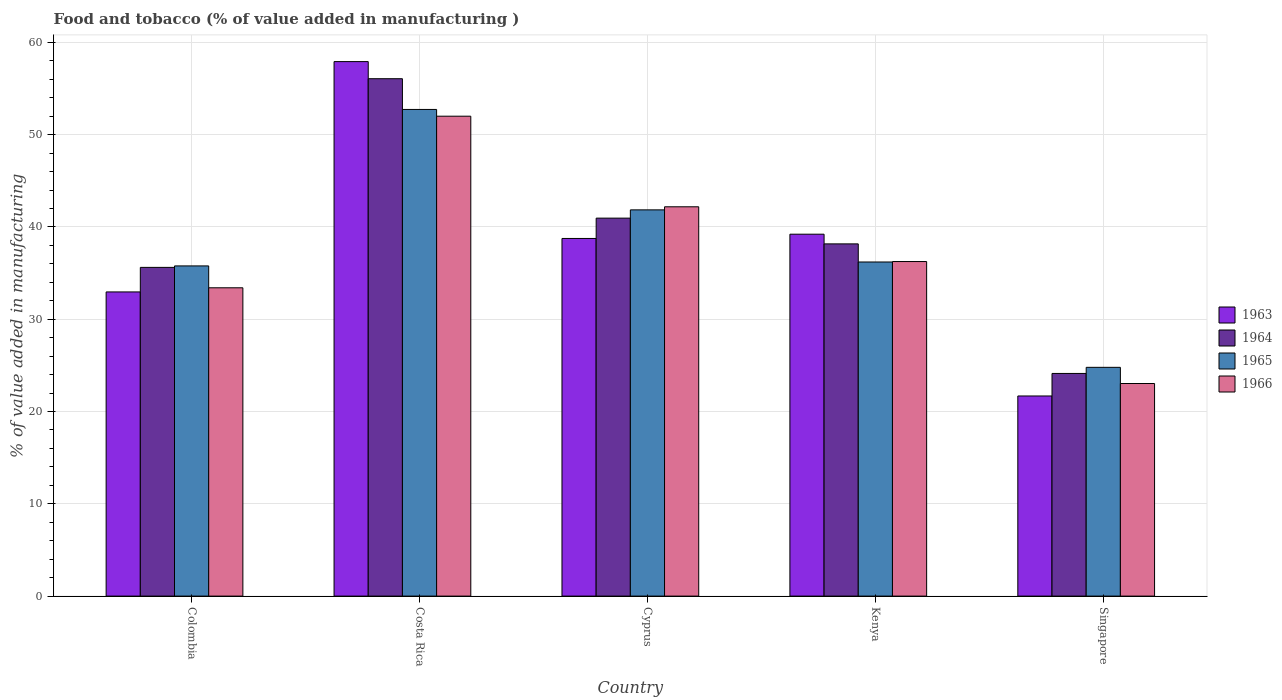How many groups of bars are there?
Your response must be concise. 5. Are the number of bars per tick equal to the number of legend labels?
Your response must be concise. Yes. Are the number of bars on each tick of the X-axis equal?
Offer a terse response. Yes. How many bars are there on the 2nd tick from the left?
Your answer should be compact. 4. What is the label of the 4th group of bars from the left?
Give a very brief answer. Kenya. What is the value added in manufacturing food and tobacco in 1964 in Colombia?
Keep it short and to the point. 35.62. Across all countries, what is the maximum value added in manufacturing food and tobacco in 1964?
Ensure brevity in your answer.  56.07. Across all countries, what is the minimum value added in manufacturing food and tobacco in 1965?
Keep it short and to the point. 24.79. In which country was the value added in manufacturing food and tobacco in 1964 maximum?
Your response must be concise. Costa Rica. In which country was the value added in manufacturing food and tobacco in 1966 minimum?
Provide a short and direct response. Singapore. What is the total value added in manufacturing food and tobacco in 1964 in the graph?
Provide a succinct answer. 194.94. What is the difference between the value added in manufacturing food and tobacco in 1964 in Costa Rica and that in Cyprus?
Offer a very short reply. 15.11. What is the difference between the value added in manufacturing food and tobacco in 1965 in Cyprus and the value added in manufacturing food and tobacco in 1964 in Kenya?
Provide a succinct answer. 3.69. What is the average value added in manufacturing food and tobacco in 1965 per country?
Provide a short and direct response. 38.27. What is the difference between the value added in manufacturing food and tobacco of/in 1963 and value added in manufacturing food and tobacco of/in 1966 in Singapore?
Make the answer very short. -1.35. What is the ratio of the value added in manufacturing food and tobacco in 1964 in Cyprus to that in Kenya?
Ensure brevity in your answer.  1.07. Is the difference between the value added in manufacturing food and tobacco in 1963 in Kenya and Singapore greater than the difference between the value added in manufacturing food and tobacco in 1966 in Kenya and Singapore?
Give a very brief answer. Yes. What is the difference between the highest and the second highest value added in manufacturing food and tobacco in 1964?
Offer a very short reply. 15.11. What is the difference between the highest and the lowest value added in manufacturing food and tobacco in 1965?
Make the answer very short. 27.94. In how many countries, is the value added in manufacturing food and tobacco in 1965 greater than the average value added in manufacturing food and tobacco in 1965 taken over all countries?
Provide a succinct answer. 2. Is the sum of the value added in manufacturing food and tobacco in 1965 in Costa Rica and Singapore greater than the maximum value added in manufacturing food and tobacco in 1966 across all countries?
Ensure brevity in your answer.  Yes. Is it the case that in every country, the sum of the value added in manufacturing food and tobacco in 1963 and value added in manufacturing food and tobacco in 1964 is greater than the sum of value added in manufacturing food and tobacco in 1965 and value added in manufacturing food and tobacco in 1966?
Your answer should be compact. No. What does the 1st bar from the right in Cyprus represents?
Offer a terse response. 1966. Is it the case that in every country, the sum of the value added in manufacturing food and tobacco in 1965 and value added in manufacturing food and tobacco in 1964 is greater than the value added in manufacturing food and tobacco in 1963?
Offer a terse response. Yes. How many bars are there?
Your answer should be compact. 20. Are all the bars in the graph horizontal?
Your answer should be very brief. No. How many countries are there in the graph?
Your response must be concise. 5. What is the difference between two consecutive major ticks on the Y-axis?
Provide a short and direct response. 10. Does the graph contain grids?
Provide a succinct answer. Yes. Where does the legend appear in the graph?
Keep it short and to the point. Center right. How many legend labels are there?
Give a very brief answer. 4. What is the title of the graph?
Offer a very short reply. Food and tobacco (% of value added in manufacturing ). Does "1961" appear as one of the legend labels in the graph?
Offer a terse response. No. What is the label or title of the X-axis?
Your answer should be very brief. Country. What is the label or title of the Y-axis?
Give a very brief answer. % of value added in manufacturing. What is the % of value added in manufacturing of 1963 in Colombia?
Make the answer very short. 32.96. What is the % of value added in manufacturing of 1964 in Colombia?
Your answer should be compact. 35.62. What is the % of value added in manufacturing in 1965 in Colombia?
Provide a succinct answer. 35.78. What is the % of value added in manufacturing in 1966 in Colombia?
Make the answer very short. 33.41. What is the % of value added in manufacturing of 1963 in Costa Rica?
Keep it short and to the point. 57.92. What is the % of value added in manufacturing in 1964 in Costa Rica?
Provide a short and direct response. 56.07. What is the % of value added in manufacturing in 1965 in Costa Rica?
Ensure brevity in your answer.  52.73. What is the % of value added in manufacturing of 1966 in Costa Rica?
Provide a succinct answer. 52. What is the % of value added in manufacturing of 1963 in Cyprus?
Offer a terse response. 38.75. What is the % of value added in manufacturing of 1964 in Cyprus?
Your response must be concise. 40.96. What is the % of value added in manufacturing of 1965 in Cyprus?
Offer a very short reply. 41.85. What is the % of value added in manufacturing in 1966 in Cyprus?
Make the answer very short. 42.19. What is the % of value added in manufacturing of 1963 in Kenya?
Ensure brevity in your answer.  39.22. What is the % of value added in manufacturing of 1964 in Kenya?
Ensure brevity in your answer.  38.17. What is the % of value added in manufacturing of 1965 in Kenya?
Your answer should be very brief. 36.2. What is the % of value added in manufacturing of 1966 in Kenya?
Make the answer very short. 36.25. What is the % of value added in manufacturing of 1963 in Singapore?
Provide a short and direct response. 21.69. What is the % of value added in manufacturing in 1964 in Singapore?
Offer a very short reply. 24.13. What is the % of value added in manufacturing in 1965 in Singapore?
Your answer should be very brief. 24.79. What is the % of value added in manufacturing in 1966 in Singapore?
Your response must be concise. 23.04. Across all countries, what is the maximum % of value added in manufacturing in 1963?
Provide a short and direct response. 57.92. Across all countries, what is the maximum % of value added in manufacturing in 1964?
Your response must be concise. 56.07. Across all countries, what is the maximum % of value added in manufacturing in 1965?
Your answer should be compact. 52.73. Across all countries, what is the maximum % of value added in manufacturing in 1966?
Provide a succinct answer. 52. Across all countries, what is the minimum % of value added in manufacturing of 1963?
Keep it short and to the point. 21.69. Across all countries, what is the minimum % of value added in manufacturing in 1964?
Your answer should be very brief. 24.13. Across all countries, what is the minimum % of value added in manufacturing of 1965?
Your response must be concise. 24.79. Across all countries, what is the minimum % of value added in manufacturing in 1966?
Your answer should be compact. 23.04. What is the total % of value added in manufacturing of 1963 in the graph?
Offer a terse response. 190.54. What is the total % of value added in manufacturing of 1964 in the graph?
Keep it short and to the point. 194.94. What is the total % of value added in manufacturing of 1965 in the graph?
Offer a very short reply. 191.36. What is the total % of value added in manufacturing in 1966 in the graph?
Your response must be concise. 186.89. What is the difference between the % of value added in manufacturing of 1963 in Colombia and that in Costa Rica?
Give a very brief answer. -24.96. What is the difference between the % of value added in manufacturing in 1964 in Colombia and that in Costa Rica?
Ensure brevity in your answer.  -20.45. What is the difference between the % of value added in manufacturing in 1965 in Colombia and that in Costa Rica?
Keep it short and to the point. -16.95. What is the difference between the % of value added in manufacturing of 1966 in Colombia and that in Costa Rica?
Make the answer very short. -18.59. What is the difference between the % of value added in manufacturing in 1963 in Colombia and that in Cyprus?
Ensure brevity in your answer.  -5.79. What is the difference between the % of value added in manufacturing in 1964 in Colombia and that in Cyprus?
Provide a short and direct response. -5.34. What is the difference between the % of value added in manufacturing of 1965 in Colombia and that in Cyprus?
Make the answer very short. -6.07. What is the difference between the % of value added in manufacturing in 1966 in Colombia and that in Cyprus?
Offer a very short reply. -8.78. What is the difference between the % of value added in manufacturing of 1963 in Colombia and that in Kenya?
Ensure brevity in your answer.  -6.26. What is the difference between the % of value added in manufacturing in 1964 in Colombia and that in Kenya?
Give a very brief answer. -2.55. What is the difference between the % of value added in manufacturing in 1965 in Colombia and that in Kenya?
Give a very brief answer. -0.42. What is the difference between the % of value added in manufacturing of 1966 in Colombia and that in Kenya?
Ensure brevity in your answer.  -2.84. What is the difference between the % of value added in manufacturing of 1963 in Colombia and that in Singapore?
Your answer should be very brief. 11.27. What is the difference between the % of value added in manufacturing of 1964 in Colombia and that in Singapore?
Provide a short and direct response. 11.49. What is the difference between the % of value added in manufacturing in 1965 in Colombia and that in Singapore?
Provide a succinct answer. 10.99. What is the difference between the % of value added in manufacturing in 1966 in Colombia and that in Singapore?
Your response must be concise. 10.37. What is the difference between the % of value added in manufacturing in 1963 in Costa Rica and that in Cyprus?
Give a very brief answer. 19.17. What is the difference between the % of value added in manufacturing of 1964 in Costa Rica and that in Cyprus?
Offer a terse response. 15.11. What is the difference between the % of value added in manufacturing of 1965 in Costa Rica and that in Cyprus?
Keep it short and to the point. 10.88. What is the difference between the % of value added in manufacturing in 1966 in Costa Rica and that in Cyprus?
Your answer should be compact. 9.82. What is the difference between the % of value added in manufacturing of 1963 in Costa Rica and that in Kenya?
Your answer should be very brief. 18.7. What is the difference between the % of value added in manufacturing in 1964 in Costa Rica and that in Kenya?
Your answer should be compact. 17.9. What is the difference between the % of value added in manufacturing of 1965 in Costa Rica and that in Kenya?
Your response must be concise. 16.53. What is the difference between the % of value added in manufacturing of 1966 in Costa Rica and that in Kenya?
Your answer should be compact. 15.75. What is the difference between the % of value added in manufacturing in 1963 in Costa Rica and that in Singapore?
Give a very brief answer. 36.23. What is the difference between the % of value added in manufacturing of 1964 in Costa Rica and that in Singapore?
Offer a terse response. 31.94. What is the difference between the % of value added in manufacturing of 1965 in Costa Rica and that in Singapore?
Make the answer very short. 27.94. What is the difference between the % of value added in manufacturing of 1966 in Costa Rica and that in Singapore?
Ensure brevity in your answer.  28.97. What is the difference between the % of value added in manufacturing of 1963 in Cyprus and that in Kenya?
Your answer should be compact. -0.46. What is the difference between the % of value added in manufacturing of 1964 in Cyprus and that in Kenya?
Provide a succinct answer. 2.79. What is the difference between the % of value added in manufacturing of 1965 in Cyprus and that in Kenya?
Your answer should be compact. 5.65. What is the difference between the % of value added in manufacturing of 1966 in Cyprus and that in Kenya?
Your response must be concise. 5.93. What is the difference between the % of value added in manufacturing of 1963 in Cyprus and that in Singapore?
Provide a succinct answer. 17.07. What is the difference between the % of value added in manufacturing of 1964 in Cyprus and that in Singapore?
Your response must be concise. 16.83. What is the difference between the % of value added in manufacturing of 1965 in Cyprus and that in Singapore?
Provide a succinct answer. 17.06. What is the difference between the % of value added in manufacturing in 1966 in Cyprus and that in Singapore?
Your answer should be very brief. 19.15. What is the difference between the % of value added in manufacturing of 1963 in Kenya and that in Singapore?
Give a very brief answer. 17.53. What is the difference between the % of value added in manufacturing of 1964 in Kenya and that in Singapore?
Provide a short and direct response. 14.04. What is the difference between the % of value added in manufacturing in 1965 in Kenya and that in Singapore?
Keep it short and to the point. 11.41. What is the difference between the % of value added in manufacturing in 1966 in Kenya and that in Singapore?
Your answer should be compact. 13.22. What is the difference between the % of value added in manufacturing of 1963 in Colombia and the % of value added in manufacturing of 1964 in Costa Rica?
Offer a terse response. -23.11. What is the difference between the % of value added in manufacturing of 1963 in Colombia and the % of value added in manufacturing of 1965 in Costa Rica?
Keep it short and to the point. -19.77. What is the difference between the % of value added in manufacturing of 1963 in Colombia and the % of value added in manufacturing of 1966 in Costa Rica?
Your response must be concise. -19.04. What is the difference between the % of value added in manufacturing in 1964 in Colombia and the % of value added in manufacturing in 1965 in Costa Rica?
Offer a very short reply. -17.11. What is the difference between the % of value added in manufacturing of 1964 in Colombia and the % of value added in manufacturing of 1966 in Costa Rica?
Give a very brief answer. -16.38. What is the difference between the % of value added in manufacturing in 1965 in Colombia and the % of value added in manufacturing in 1966 in Costa Rica?
Your answer should be very brief. -16.22. What is the difference between the % of value added in manufacturing of 1963 in Colombia and the % of value added in manufacturing of 1964 in Cyprus?
Offer a very short reply. -8. What is the difference between the % of value added in manufacturing of 1963 in Colombia and the % of value added in manufacturing of 1965 in Cyprus?
Provide a short and direct response. -8.89. What is the difference between the % of value added in manufacturing in 1963 in Colombia and the % of value added in manufacturing in 1966 in Cyprus?
Ensure brevity in your answer.  -9.23. What is the difference between the % of value added in manufacturing in 1964 in Colombia and the % of value added in manufacturing in 1965 in Cyprus?
Ensure brevity in your answer.  -6.23. What is the difference between the % of value added in manufacturing in 1964 in Colombia and the % of value added in manufacturing in 1966 in Cyprus?
Your answer should be very brief. -6.57. What is the difference between the % of value added in manufacturing in 1965 in Colombia and the % of value added in manufacturing in 1966 in Cyprus?
Provide a succinct answer. -6.41. What is the difference between the % of value added in manufacturing in 1963 in Colombia and the % of value added in manufacturing in 1964 in Kenya?
Provide a succinct answer. -5.21. What is the difference between the % of value added in manufacturing of 1963 in Colombia and the % of value added in manufacturing of 1965 in Kenya?
Ensure brevity in your answer.  -3.24. What is the difference between the % of value added in manufacturing of 1963 in Colombia and the % of value added in manufacturing of 1966 in Kenya?
Provide a succinct answer. -3.29. What is the difference between the % of value added in manufacturing in 1964 in Colombia and the % of value added in manufacturing in 1965 in Kenya?
Give a very brief answer. -0.58. What is the difference between the % of value added in manufacturing of 1964 in Colombia and the % of value added in manufacturing of 1966 in Kenya?
Offer a terse response. -0.63. What is the difference between the % of value added in manufacturing in 1965 in Colombia and the % of value added in manufacturing in 1966 in Kenya?
Offer a very short reply. -0.47. What is the difference between the % of value added in manufacturing of 1963 in Colombia and the % of value added in manufacturing of 1964 in Singapore?
Provide a succinct answer. 8.83. What is the difference between the % of value added in manufacturing of 1963 in Colombia and the % of value added in manufacturing of 1965 in Singapore?
Provide a succinct answer. 8.17. What is the difference between the % of value added in manufacturing in 1963 in Colombia and the % of value added in manufacturing in 1966 in Singapore?
Ensure brevity in your answer.  9.92. What is the difference between the % of value added in manufacturing in 1964 in Colombia and the % of value added in manufacturing in 1965 in Singapore?
Keep it short and to the point. 10.83. What is the difference between the % of value added in manufacturing in 1964 in Colombia and the % of value added in manufacturing in 1966 in Singapore?
Provide a succinct answer. 12.58. What is the difference between the % of value added in manufacturing in 1965 in Colombia and the % of value added in manufacturing in 1966 in Singapore?
Provide a succinct answer. 12.74. What is the difference between the % of value added in manufacturing of 1963 in Costa Rica and the % of value added in manufacturing of 1964 in Cyprus?
Offer a very short reply. 16.96. What is the difference between the % of value added in manufacturing of 1963 in Costa Rica and the % of value added in manufacturing of 1965 in Cyprus?
Your response must be concise. 16.07. What is the difference between the % of value added in manufacturing of 1963 in Costa Rica and the % of value added in manufacturing of 1966 in Cyprus?
Your answer should be compact. 15.73. What is the difference between the % of value added in manufacturing of 1964 in Costa Rica and the % of value added in manufacturing of 1965 in Cyprus?
Offer a terse response. 14.21. What is the difference between the % of value added in manufacturing of 1964 in Costa Rica and the % of value added in manufacturing of 1966 in Cyprus?
Your response must be concise. 13.88. What is the difference between the % of value added in manufacturing of 1965 in Costa Rica and the % of value added in manufacturing of 1966 in Cyprus?
Keep it short and to the point. 10.55. What is the difference between the % of value added in manufacturing of 1963 in Costa Rica and the % of value added in manufacturing of 1964 in Kenya?
Provide a succinct answer. 19.75. What is the difference between the % of value added in manufacturing of 1963 in Costa Rica and the % of value added in manufacturing of 1965 in Kenya?
Offer a terse response. 21.72. What is the difference between the % of value added in manufacturing in 1963 in Costa Rica and the % of value added in manufacturing in 1966 in Kenya?
Offer a terse response. 21.67. What is the difference between the % of value added in manufacturing of 1964 in Costa Rica and the % of value added in manufacturing of 1965 in Kenya?
Make the answer very short. 19.86. What is the difference between the % of value added in manufacturing of 1964 in Costa Rica and the % of value added in manufacturing of 1966 in Kenya?
Make the answer very short. 19.81. What is the difference between the % of value added in manufacturing of 1965 in Costa Rica and the % of value added in manufacturing of 1966 in Kenya?
Give a very brief answer. 16.48. What is the difference between the % of value added in manufacturing in 1963 in Costa Rica and the % of value added in manufacturing in 1964 in Singapore?
Keep it short and to the point. 33.79. What is the difference between the % of value added in manufacturing in 1963 in Costa Rica and the % of value added in manufacturing in 1965 in Singapore?
Make the answer very short. 33.13. What is the difference between the % of value added in manufacturing in 1963 in Costa Rica and the % of value added in manufacturing in 1966 in Singapore?
Your response must be concise. 34.88. What is the difference between the % of value added in manufacturing in 1964 in Costa Rica and the % of value added in manufacturing in 1965 in Singapore?
Ensure brevity in your answer.  31.28. What is the difference between the % of value added in manufacturing in 1964 in Costa Rica and the % of value added in manufacturing in 1966 in Singapore?
Make the answer very short. 33.03. What is the difference between the % of value added in manufacturing of 1965 in Costa Rica and the % of value added in manufacturing of 1966 in Singapore?
Give a very brief answer. 29.7. What is the difference between the % of value added in manufacturing of 1963 in Cyprus and the % of value added in manufacturing of 1964 in Kenya?
Ensure brevity in your answer.  0.59. What is the difference between the % of value added in manufacturing in 1963 in Cyprus and the % of value added in manufacturing in 1965 in Kenya?
Make the answer very short. 2.55. What is the difference between the % of value added in manufacturing in 1963 in Cyprus and the % of value added in manufacturing in 1966 in Kenya?
Your answer should be compact. 2.5. What is the difference between the % of value added in manufacturing of 1964 in Cyprus and the % of value added in manufacturing of 1965 in Kenya?
Provide a short and direct response. 4.75. What is the difference between the % of value added in manufacturing in 1964 in Cyprus and the % of value added in manufacturing in 1966 in Kenya?
Ensure brevity in your answer.  4.7. What is the difference between the % of value added in manufacturing of 1965 in Cyprus and the % of value added in manufacturing of 1966 in Kenya?
Offer a terse response. 5.6. What is the difference between the % of value added in manufacturing in 1963 in Cyprus and the % of value added in manufacturing in 1964 in Singapore?
Provide a short and direct response. 14.63. What is the difference between the % of value added in manufacturing in 1963 in Cyprus and the % of value added in manufacturing in 1965 in Singapore?
Your answer should be very brief. 13.96. What is the difference between the % of value added in manufacturing of 1963 in Cyprus and the % of value added in manufacturing of 1966 in Singapore?
Offer a very short reply. 15.72. What is the difference between the % of value added in manufacturing in 1964 in Cyprus and the % of value added in manufacturing in 1965 in Singapore?
Ensure brevity in your answer.  16.17. What is the difference between the % of value added in manufacturing in 1964 in Cyprus and the % of value added in manufacturing in 1966 in Singapore?
Your answer should be compact. 17.92. What is the difference between the % of value added in manufacturing of 1965 in Cyprus and the % of value added in manufacturing of 1966 in Singapore?
Provide a short and direct response. 18.82. What is the difference between the % of value added in manufacturing in 1963 in Kenya and the % of value added in manufacturing in 1964 in Singapore?
Offer a very short reply. 15.09. What is the difference between the % of value added in manufacturing in 1963 in Kenya and the % of value added in manufacturing in 1965 in Singapore?
Give a very brief answer. 14.43. What is the difference between the % of value added in manufacturing in 1963 in Kenya and the % of value added in manufacturing in 1966 in Singapore?
Your answer should be compact. 16.18. What is the difference between the % of value added in manufacturing in 1964 in Kenya and the % of value added in manufacturing in 1965 in Singapore?
Offer a very short reply. 13.38. What is the difference between the % of value added in manufacturing of 1964 in Kenya and the % of value added in manufacturing of 1966 in Singapore?
Provide a succinct answer. 15.13. What is the difference between the % of value added in manufacturing in 1965 in Kenya and the % of value added in manufacturing in 1966 in Singapore?
Your response must be concise. 13.17. What is the average % of value added in manufacturing in 1963 per country?
Provide a succinct answer. 38.11. What is the average % of value added in manufacturing in 1964 per country?
Your answer should be very brief. 38.99. What is the average % of value added in manufacturing in 1965 per country?
Your answer should be compact. 38.27. What is the average % of value added in manufacturing in 1966 per country?
Offer a terse response. 37.38. What is the difference between the % of value added in manufacturing of 1963 and % of value added in manufacturing of 1964 in Colombia?
Ensure brevity in your answer.  -2.66. What is the difference between the % of value added in manufacturing in 1963 and % of value added in manufacturing in 1965 in Colombia?
Make the answer very short. -2.82. What is the difference between the % of value added in manufacturing of 1963 and % of value added in manufacturing of 1966 in Colombia?
Offer a very short reply. -0.45. What is the difference between the % of value added in manufacturing of 1964 and % of value added in manufacturing of 1965 in Colombia?
Provide a short and direct response. -0.16. What is the difference between the % of value added in manufacturing in 1964 and % of value added in manufacturing in 1966 in Colombia?
Keep it short and to the point. 2.21. What is the difference between the % of value added in manufacturing of 1965 and % of value added in manufacturing of 1966 in Colombia?
Provide a succinct answer. 2.37. What is the difference between the % of value added in manufacturing of 1963 and % of value added in manufacturing of 1964 in Costa Rica?
Offer a very short reply. 1.85. What is the difference between the % of value added in manufacturing of 1963 and % of value added in manufacturing of 1965 in Costa Rica?
Make the answer very short. 5.19. What is the difference between the % of value added in manufacturing in 1963 and % of value added in manufacturing in 1966 in Costa Rica?
Your answer should be compact. 5.92. What is the difference between the % of value added in manufacturing in 1964 and % of value added in manufacturing in 1965 in Costa Rica?
Provide a succinct answer. 3.33. What is the difference between the % of value added in manufacturing in 1964 and % of value added in manufacturing in 1966 in Costa Rica?
Provide a short and direct response. 4.06. What is the difference between the % of value added in manufacturing of 1965 and % of value added in manufacturing of 1966 in Costa Rica?
Keep it short and to the point. 0.73. What is the difference between the % of value added in manufacturing of 1963 and % of value added in manufacturing of 1964 in Cyprus?
Give a very brief answer. -2.2. What is the difference between the % of value added in manufacturing in 1963 and % of value added in manufacturing in 1965 in Cyprus?
Your answer should be compact. -3.1. What is the difference between the % of value added in manufacturing in 1963 and % of value added in manufacturing in 1966 in Cyprus?
Your answer should be very brief. -3.43. What is the difference between the % of value added in manufacturing of 1964 and % of value added in manufacturing of 1965 in Cyprus?
Provide a short and direct response. -0.9. What is the difference between the % of value added in manufacturing in 1964 and % of value added in manufacturing in 1966 in Cyprus?
Provide a succinct answer. -1.23. What is the difference between the % of value added in manufacturing of 1963 and % of value added in manufacturing of 1964 in Kenya?
Your response must be concise. 1.05. What is the difference between the % of value added in manufacturing of 1963 and % of value added in manufacturing of 1965 in Kenya?
Offer a very short reply. 3.01. What is the difference between the % of value added in manufacturing of 1963 and % of value added in manufacturing of 1966 in Kenya?
Provide a short and direct response. 2.96. What is the difference between the % of value added in manufacturing of 1964 and % of value added in manufacturing of 1965 in Kenya?
Provide a succinct answer. 1.96. What is the difference between the % of value added in manufacturing in 1964 and % of value added in manufacturing in 1966 in Kenya?
Your answer should be very brief. 1.91. What is the difference between the % of value added in manufacturing of 1963 and % of value added in manufacturing of 1964 in Singapore?
Your response must be concise. -2.44. What is the difference between the % of value added in manufacturing of 1963 and % of value added in manufacturing of 1965 in Singapore?
Give a very brief answer. -3.1. What is the difference between the % of value added in manufacturing in 1963 and % of value added in manufacturing in 1966 in Singapore?
Offer a very short reply. -1.35. What is the difference between the % of value added in manufacturing of 1964 and % of value added in manufacturing of 1965 in Singapore?
Make the answer very short. -0.66. What is the difference between the % of value added in manufacturing in 1964 and % of value added in manufacturing in 1966 in Singapore?
Provide a short and direct response. 1.09. What is the difference between the % of value added in manufacturing in 1965 and % of value added in manufacturing in 1966 in Singapore?
Provide a short and direct response. 1.75. What is the ratio of the % of value added in manufacturing of 1963 in Colombia to that in Costa Rica?
Offer a terse response. 0.57. What is the ratio of the % of value added in manufacturing in 1964 in Colombia to that in Costa Rica?
Make the answer very short. 0.64. What is the ratio of the % of value added in manufacturing of 1965 in Colombia to that in Costa Rica?
Offer a terse response. 0.68. What is the ratio of the % of value added in manufacturing of 1966 in Colombia to that in Costa Rica?
Offer a terse response. 0.64. What is the ratio of the % of value added in manufacturing of 1963 in Colombia to that in Cyprus?
Offer a very short reply. 0.85. What is the ratio of the % of value added in manufacturing in 1964 in Colombia to that in Cyprus?
Keep it short and to the point. 0.87. What is the ratio of the % of value added in manufacturing in 1965 in Colombia to that in Cyprus?
Offer a very short reply. 0.85. What is the ratio of the % of value added in manufacturing of 1966 in Colombia to that in Cyprus?
Provide a short and direct response. 0.79. What is the ratio of the % of value added in manufacturing in 1963 in Colombia to that in Kenya?
Your answer should be compact. 0.84. What is the ratio of the % of value added in manufacturing in 1964 in Colombia to that in Kenya?
Make the answer very short. 0.93. What is the ratio of the % of value added in manufacturing of 1965 in Colombia to that in Kenya?
Offer a terse response. 0.99. What is the ratio of the % of value added in manufacturing in 1966 in Colombia to that in Kenya?
Provide a short and direct response. 0.92. What is the ratio of the % of value added in manufacturing in 1963 in Colombia to that in Singapore?
Offer a terse response. 1.52. What is the ratio of the % of value added in manufacturing of 1964 in Colombia to that in Singapore?
Offer a very short reply. 1.48. What is the ratio of the % of value added in manufacturing of 1965 in Colombia to that in Singapore?
Your response must be concise. 1.44. What is the ratio of the % of value added in manufacturing in 1966 in Colombia to that in Singapore?
Your answer should be very brief. 1.45. What is the ratio of the % of value added in manufacturing in 1963 in Costa Rica to that in Cyprus?
Offer a terse response. 1.49. What is the ratio of the % of value added in manufacturing in 1964 in Costa Rica to that in Cyprus?
Offer a very short reply. 1.37. What is the ratio of the % of value added in manufacturing in 1965 in Costa Rica to that in Cyprus?
Give a very brief answer. 1.26. What is the ratio of the % of value added in manufacturing of 1966 in Costa Rica to that in Cyprus?
Offer a very short reply. 1.23. What is the ratio of the % of value added in manufacturing in 1963 in Costa Rica to that in Kenya?
Make the answer very short. 1.48. What is the ratio of the % of value added in manufacturing of 1964 in Costa Rica to that in Kenya?
Your response must be concise. 1.47. What is the ratio of the % of value added in manufacturing of 1965 in Costa Rica to that in Kenya?
Provide a short and direct response. 1.46. What is the ratio of the % of value added in manufacturing in 1966 in Costa Rica to that in Kenya?
Your answer should be compact. 1.43. What is the ratio of the % of value added in manufacturing in 1963 in Costa Rica to that in Singapore?
Your answer should be very brief. 2.67. What is the ratio of the % of value added in manufacturing in 1964 in Costa Rica to that in Singapore?
Your response must be concise. 2.32. What is the ratio of the % of value added in manufacturing in 1965 in Costa Rica to that in Singapore?
Your answer should be very brief. 2.13. What is the ratio of the % of value added in manufacturing in 1966 in Costa Rica to that in Singapore?
Keep it short and to the point. 2.26. What is the ratio of the % of value added in manufacturing in 1964 in Cyprus to that in Kenya?
Offer a very short reply. 1.07. What is the ratio of the % of value added in manufacturing of 1965 in Cyprus to that in Kenya?
Give a very brief answer. 1.16. What is the ratio of the % of value added in manufacturing of 1966 in Cyprus to that in Kenya?
Make the answer very short. 1.16. What is the ratio of the % of value added in manufacturing of 1963 in Cyprus to that in Singapore?
Provide a succinct answer. 1.79. What is the ratio of the % of value added in manufacturing of 1964 in Cyprus to that in Singapore?
Provide a short and direct response. 1.7. What is the ratio of the % of value added in manufacturing in 1965 in Cyprus to that in Singapore?
Provide a succinct answer. 1.69. What is the ratio of the % of value added in manufacturing in 1966 in Cyprus to that in Singapore?
Give a very brief answer. 1.83. What is the ratio of the % of value added in manufacturing of 1963 in Kenya to that in Singapore?
Offer a very short reply. 1.81. What is the ratio of the % of value added in manufacturing in 1964 in Kenya to that in Singapore?
Offer a terse response. 1.58. What is the ratio of the % of value added in manufacturing in 1965 in Kenya to that in Singapore?
Keep it short and to the point. 1.46. What is the ratio of the % of value added in manufacturing of 1966 in Kenya to that in Singapore?
Keep it short and to the point. 1.57. What is the difference between the highest and the second highest % of value added in manufacturing of 1963?
Your answer should be compact. 18.7. What is the difference between the highest and the second highest % of value added in manufacturing of 1964?
Ensure brevity in your answer.  15.11. What is the difference between the highest and the second highest % of value added in manufacturing in 1965?
Offer a very short reply. 10.88. What is the difference between the highest and the second highest % of value added in manufacturing of 1966?
Ensure brevity in your answer.  9.82. What is the difference between the highest and the lowest % of value added in manufacturing of 1963?
Provide a succinct answer. 36.23. What is the difference between the highest and the lowest % of value added in manufacturing in 1964?
Make the answer very short. 31.94. What is the difference between the highest and the lowest % of value added in manufacturing in 1965?
Your answer should be compact. 27.94. What is the difference between the highest and the lowest % of value added in manufacturing of 1966?
Offer a terse response. 28.97. 